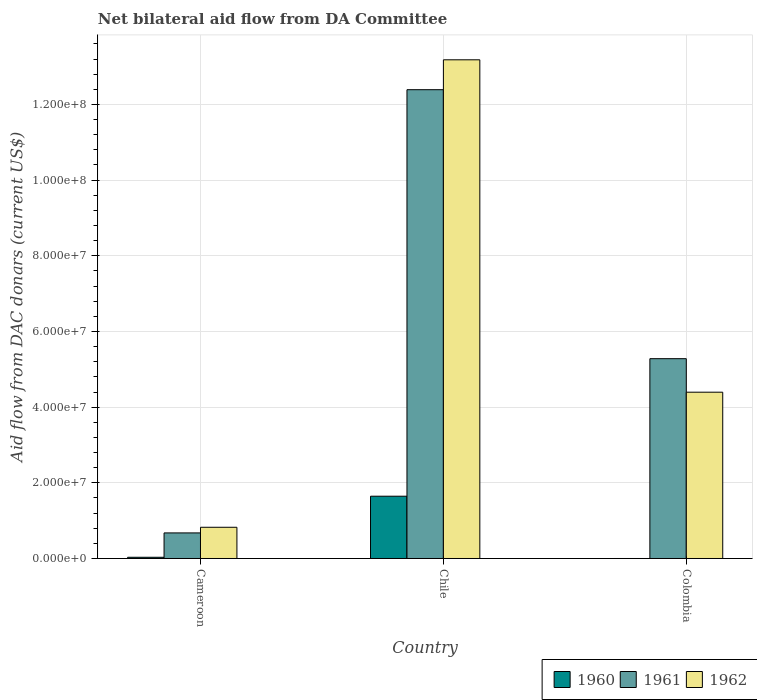How many different coloured bars are there?
Provide a short and direct response. 3. Are the number of bars per tick equal to the number of legend labels?
Provide a succinct answer. No. How many bars are there on the 2nd tick from the left?
Give a very brief answer. 3. What is the label of the 1st group of bars from the left?
Provide a succinct answer. Cameroon. What is the aid flow in in 1962 in Cameroon?
Keep it short and to the point. 8.25e+06. Across all countries, what is the maximum aid flow in in 1960?
Make the answer very short. 1.65e+07. Across all countries, what is the minimum aid flow in in 1961?
Keep it short and to the point. 6.76e+06. What is the total aid flow in in 1960 in the graph?
Your answer should be very brief. 1.68e+07. What is the difference between the aid flow in in 1961 in Cameroon and that in Colombia?
Make the answer very short. -4.60e+07. What is the difference between the aid flow in in 1960 in Cameroon and the aid flow in in 1961 in Colombia?
Your answer should be compact. -5.25e+07. What is the average aid flow in in 1961 per country?
Your answer should be compact. 6.12e+07. What is the difference between the aid flow in of/in 1961 and aid flow in of/in 1962 in Colombia?
Offer a terse response. 8.86e+06. What is the ratio of the aid flow in in 1962 in Cameroon to that in Colombia?
Make the answer very short. 0.19. Is the aid flow in in 1961 in Cameroon less than that in Colombia?
Your answer should be very brief. Yes. Is the difference between the aid flow in in 1961 in Cameroon and Colombia greater than the difference between the aid flow in in 1962 in Cameroon and Colombia?
Your answer should be compact. No. What is the difference between the highest and the second highest aid flow in in 1961?
Your answer should be compact. 7.11e+07. What is the difference between the highest and the lowest aid flow in in 1960?
Offer a terse response. 1.65e+07. In how many countries, is the aid flow in in 1962 greater than the average aid flow in in 1962 taken over all countries?
Your response must be concise. 1. Is the sum of the aid flow in in 1960 in Cameroon and Chile greater than the maximum aid flow in in 1962 across all countries?
Ensure brevity in your answer.  No. How many bars are there?
Provide a short and direct response. 8. Are all the bars in the graph horizontal?
Your response must be concise. No. Are the values on the major ticks of Y-axis written in scientific E-notation?
Give a very brief answer. Yes. Does the graph contain any zero values?
Provide a short and direct response. Yes. Does the graph contain grids?
Your response must be concise. Yes. How many legend labels are there?
Ensure brevity in your answer.  3. What is the title of the graph?
Provide a short and direct response. Net bilateral aid flow from DA Committee. Does "2001" appear as one of the legend labels in the graph?
Make the answer very short. No. What is the label or title of the Y-axis?
Your response must be concise. Aid flow from DAC donars (current US$). What is the Aid flow from DAC donars (current US$) in 1960 in Cameroon?
Your response must be concise. 3.20e+05. What is the Aid flow from DAC donars (current US$) in 1961 in Cameroon?
Your answer should be compact. 6.76e+06. What is the Aid flow from DAC donars (current US$) in 1962 in Cameroon?
Ensure brevity in your answer.  8.25e+06. What is the Aid flow from DAC donars (current US$) of 1960 in Chile?
Offer a terse response. 1.65e+07. What is the Aid flow from DAC donars (current US$) of 1961 in Chile?
Offer a terse response. 1.24e+08. What is the Aid flow from DAC donars (current US$) in 1962 in Chile?
Provide a succinct answer. 1.32e+08. What is the Aid flow from DAC donars (current US$) in 1961 in Colombia?
Provide a short and direct response. 5.28e+07. What is the Aid flow from DAC donars (current US$) in 1962 in Colombia?
Offer a very short reply. 4.40e+07. Across all countries, what is the maximum Aid flow from DAC donars (current US$) in 1960?
Provide a succinct answer. 1.65e+07. Across all countries, what is the maximum Aid flow from DAC donars (current US$) of 1961?
Make the answer very short. 1.24e+08. Across all countries, what is the maximum Aid flow from DAC donars (current US$) of 1962?
Provide a succinct answer. 1.32e+08. Across all countries, what is the minimum Aid flow from DAC donars (current US$) in 1960?
Provide a succinct answer. 0. Across all countries, what is the minimum Aid flow from DAC donars (current US$) in 1961?
Make the answer very short. 6.76e+06. Across all countries, what is the minimum Aid flow from DAC donars (current US$) of 1962?
Provide a succinct answer. 8.25e+06. What is the total Aid flow from DAC donars (current US$) in 1960 in the graph?
Provide a succinct answer. 1.68e+07. What is the total Aid flow from DAC donars (current US$) of 1961 in the graph?
Make the answer very short. 1.83e+08. What is the total Aid flow from DAC donars (current US$) in 1962 in the graph?
Your answer should be compact. 1.84e+08. What is the difference between the Aid flow from DAC donars (current US$) in 1960 in Cameroon and that in Chile?
Give a very brief answer. -1.61e+07. What is the difference between the Aid flow from DAC donars (current US$) in 1961 in Cameroon and that in Chile?
Give a very brief answer. -1.17e+08. What is the difference between the Aid flow from DAC donars (current US$) in 1962 in Cameroon and that in Chile?
Your answer should be compact. -1.24e+08. What is the difference between the Aid flow from DAC donars (current US$) of 1961 in Cameroon and that in Colombia?
Your answer should be very brief. -4.60e+07. What is the difference between the Aid flow from DAC donars (current US$) in 1962 in Cameroon and that in Colombia?
Give a very brief answer. -3.57e+07. What is the difference between the Aid flow from DAC donars (current US$) of 1961 in Chile and that in Colombia?
Offer a very short reply. 7.11e+07. What is the difference between the Aid flow from DAC donars (current US$) of 1962 in Chile and that in Colombia?
Give a very brief answer. 8.78e+07. What is the difference between the Aid flow from DAC donars (current US$) in 1960 in Cameroon and the Aid flow from DAC donars (current US$) in 1961 in Chile?
Give a very brief answer. -1.24e+08. What is the difference between the Aid flow from DAC donars (current US$) in 1960 in Cameroon and the Aid flow from DAC donars (current US$) in 1962 in Chile?
Your response must be concise. -1.31e+08. What is the difference between the Aid flow from DAC donars (current US$) of 1961 in Cameroon and the Aid flow from DAC donars (current US$) of 1962 in Chile?
Offer a very short reply. -1.25e+08. What is the difference between the Aid flow from DAC donars (current US$) of 1960 in Cameroon and the Aid flow from DAC donars (current US$) of 1961 in Colombia?
Ensure brevity in your answer.  -5.25e+07. What is the difference between the Aid flow from DAC donars (current US$) of 1960 in Cameroon and the Aid flow from DAC donars (current US$) of 1962 in Colombia?
Your answer should be compact. -4.36e+07. What is the difference between the Aid flow from DAC donars (current US$) in 1961 in Cameroon and the Aid flow from DAC donars (current US$) in 1962 in Colombia?
Give a very brief answer. -3.72e+07. What is the difference between the Aid flow from DAC donars (current US$) of 1960 in Chile and the Aid flow from DAC donars (current US$) of 1961 in Colombia?
Your answer should be compact. -3.64e+07. What is the difference between the Aid flow from DAC donars (current US$) in 1960 in Chile and the Aid flow from DAC donars (current US$) in 1962 in Colombia?
Your answer should be compact. -2.75e+07. What is the difference between the Aid flow from DAC donars (current US$) of 1961 in Chile and the Aid flow from DAC donars (current US$) of 1962 in Colombia?
Provide a short and direct response. 8.00e+07. What is the average Aid flow from DAC donars (current US$) of 1960 per country?
Your answer should be very brief. 5.59e+06. What is the average Aid flow from DAC donars (current US$) in 1961 per country?
Give a very brief answer. 6.12e+07. What is the average Aid flow from DAC donars (current US$) of 1962 per country?
Your answer should be very brief. 6.13e+07. What is the difference between the Aid flow from DAC donars (current US$) in 1960 and Aid flow from DAC donars (current US$) in 1961 in Cameroon?
Offer a terse response. -6.44e+06. What is the difference between the Aid flow from DAC donars (current US$) in 1960 and Aid flow from DAC donars (current US$) in 1962 in Cameroon?
Ensure brevity in your answer.  -7.93e+06. What is the difference between the Aid flow from DAC donars (current US$) in 1961 and Aid flow from DAC donars (current US$) in 1962 in Cameroon?
Provide a succinct answer. -1.49e+06. What is the difference between the Aid flow from DAC donars (current US$) of 1960 and Aid flow from DAC donars (current US$) of 1961 in Chile?
Offer a terse response. -1.07e+08. What is the difference between the Aid flow from DAC donars (current US$) of 1960 and Aid flow from DAC donars (current US$) of 1962 in Chile?
Offer a terse response. -1.15e+08. What is the difference between the Aid flow from DAC donars (current US$) of 1961 and Aid flow from DAC donars (current US$) of 1962 in Chile?
Offer a very short reply. -7.90e+06. What is the difference between the Aid flow from DAC donars (current US$) of 1961 and Aid flow from DAC donars (current US$) of 1962 in Colombia?
Offer a terse response. 8.86e+06. What is the ratio of the Aid flow from DAC donars (current US$) in 1960 in Cameroon to that in Chile?
Provide a short and direct response. 0.02. What is the ratio of the Aid flow from DAC donars (current US$) in 1961 in Cameroon to that in Chile?
Ensure brevity in your answer.  0.05. What is the ratio of the Aid flow from DAC donars (current US$) in 1962 in Cameroon to that in Chile?
Offer a very short reply. 0.06. What is the ratio of the Aid flow from DAC donars (current US$) in 1961 in Cameroon to that in Colombia?
Ensure brevity in your answer.  0.13. What is the ratio of the Aid flow from DAC donars (current US$) in 1962 in Cameroon to that in Colombia?
Give a very brief answer. 0.19. What is the ratio of the Aid flow from DAC donars (current US$) of 1961 in Chile to that in Colombia?
Provide a short and direct response. 2.35. What is the ratio of the Aid flow from DAC donars (current US$) in 1962 in Chile to that in Colombia?
Offer a very short reply. 3. What is the difference between the highest and the second highest Aid flow from DAC donars (current US$) of 1961?
Provide a short and direct response. 7.11e+07. What is the difference between the highest and the second highest Aid flow from DAC donars (current US$) in 1962?
Provide a succinct answer. 8.78e+07. What is the difference between the highest and the lowest Aid flow from DAC donars (current US$) in 1960?
Offer a terse response. 1.65e+07. What is the difference between the highest and the lowest Aid flow from DAC donars (current US$) of 1961?
Give a very brief answer. 1.17e+08. What is the difference between the highest and the lowest Aid flow from DAC donars (current US$) of 1962?
Your answer should be very brief. 1.24e+08. 